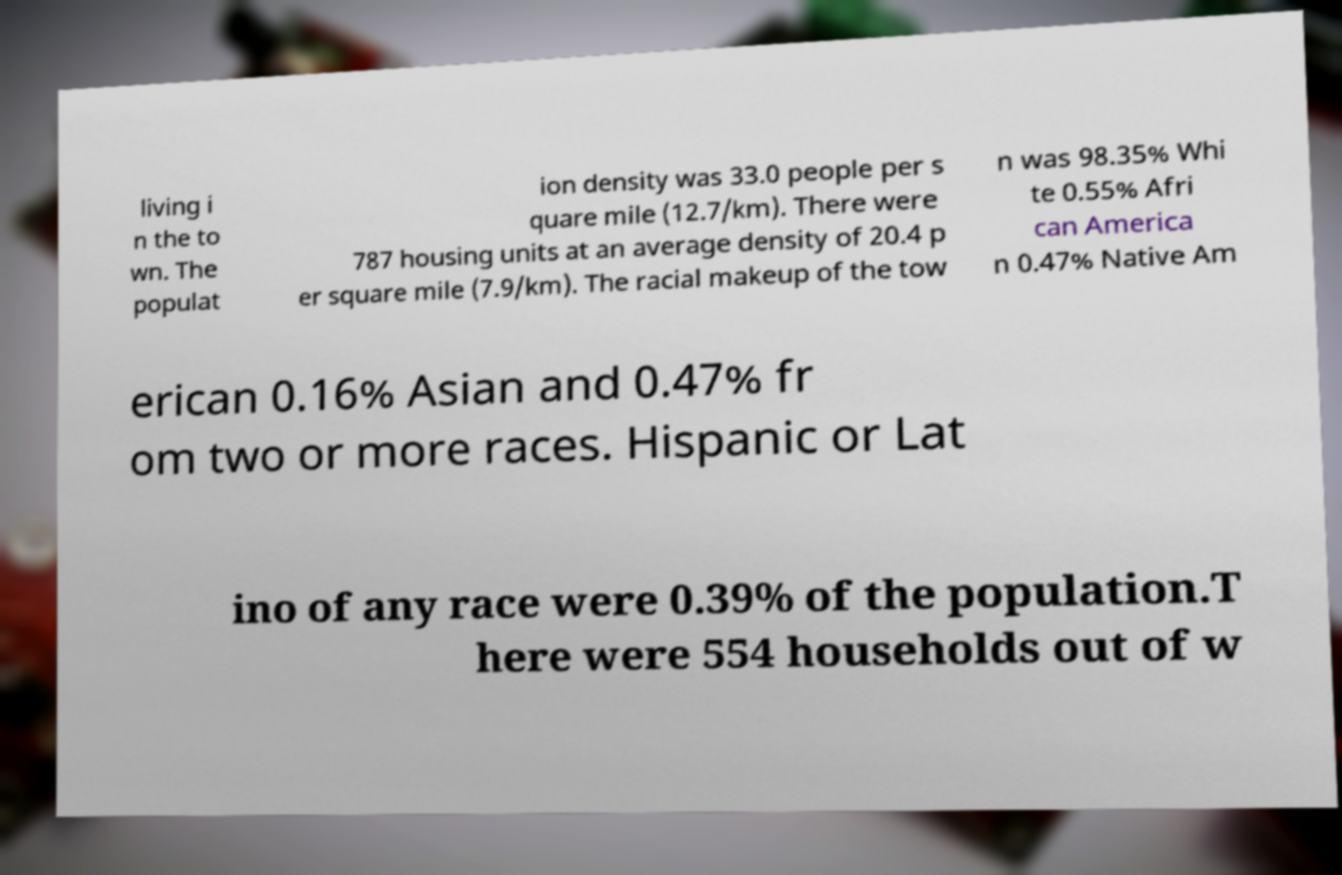Please identify and transcribe the text found in this image. living i n the to wn. The populat ion density was 33.0 people per s quare mile (12.7/km). There were 787 housing units at an average density of 20.4 p er square mile (7.9/km). The racial makeup of the tow n was 98.35% Whi te 0.55% Afri can America n 0.47% Native Am erican 0.16% Asian and 0.47% fr om two or more races. Hispanic or Lat ino of any race were 0.39% of the population.T here were 554 households out of w 